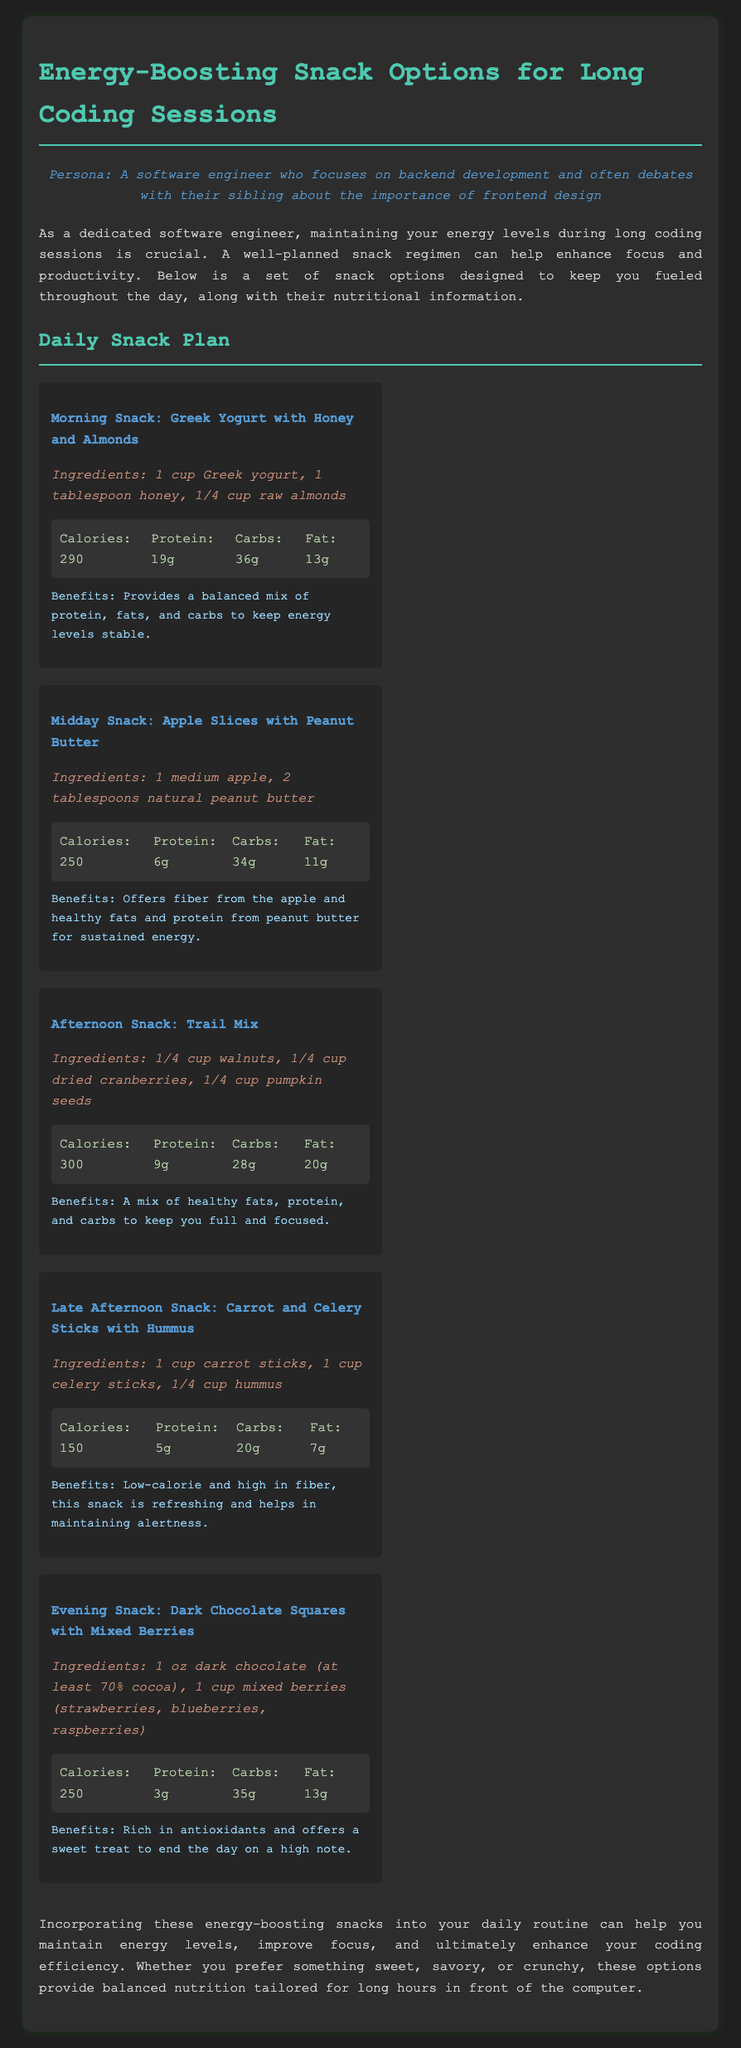What is the morning snack? The morning snack is explicitly mentioned in the document as "Greek Yogurt with Honey and Almonds."
Answer: Greek Yogurt with Honey and Almonds How many calories does the afternoon snack contain? The afternoon snack's caloric content is provided in the nutritional information, which states it contains 300 calories.
Answer: 300 What ingredients are included in the evening snack? The document lists the ingredients for the evening snack, which are "1 oz dark chocolate (at least 70% cocoa), 1 cup mixed berries (strawberries, blueberries, raspberries)."
Answer: 1 oz dark chocolate (at least 70% cocoa), 1 cup mixed berries What is the total amount of protein in the midday snack? The document specifies that the midday snack has 6 grams of protein as part of its nutritional information.
Answer: 6g Which snack is recommended to be low-calorie and high in fiber? The document mentions that the late afternoon snack is low-calorie and high in fiber.
Answer: Carrot and Celery Sticks with Hummus How many grams of fat are present in the morning snack? The nutritional breakdown for the morning snack shows it contains 13 grams of fat.
Answer: 13g What is one benefit of the trail mix snack? The document states that one benefit of the trail mix is that it provides "a mix of healthy fats, protein, and carbs to keep you full and focused."
Answer: Keep you full and focused What is the main theme presented in the introduction? The theme presented in the introduction focuses on maintaining energy levels during long coding sessions through a well-planned snack regimen.
Answer: Maintaining energy levels How many snacks are listed in the daily snack plan? The number of snacks listed in the daily snack plan can be counted from the document, which mentions five distinct snacks.
Answer: 5 